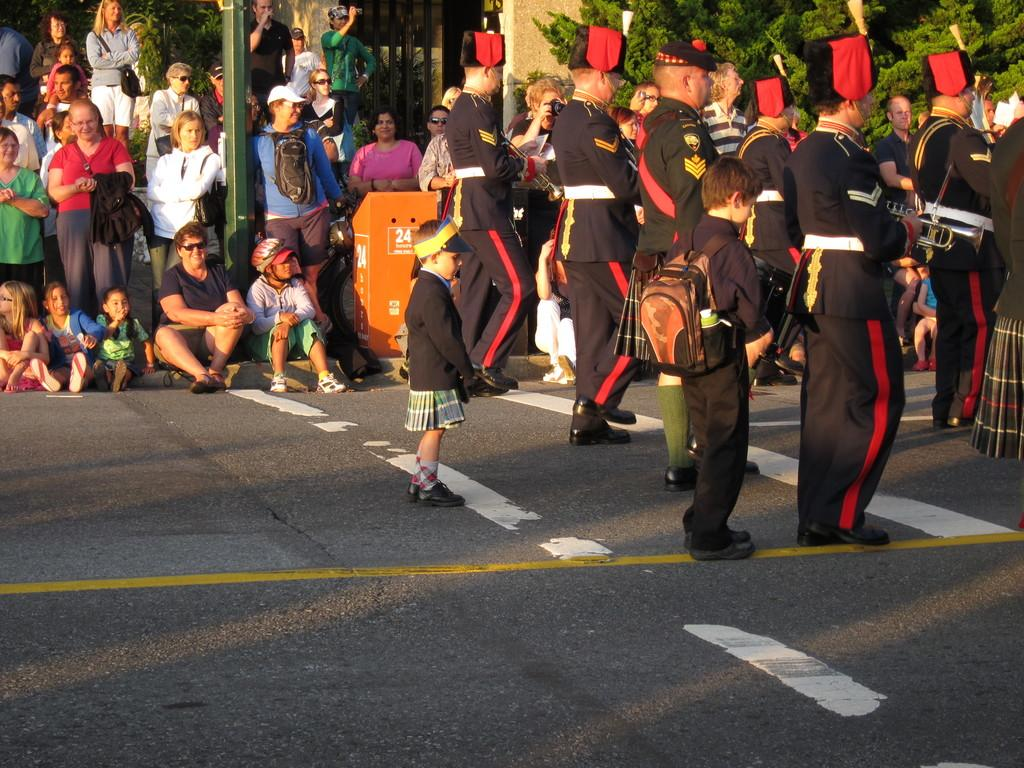What are the people in the image doing? There are people marching on a road in the image. What can be seen in the background of the image? In the background, there are people sitting on a footpath, and some people are standing. What type of vegetation is visible in the image? There are trees visible in the image. What type of oil can be seen dripping from the trees in the image? There is no oil visible in the image, and the trees do not appear to be dripping anything. 